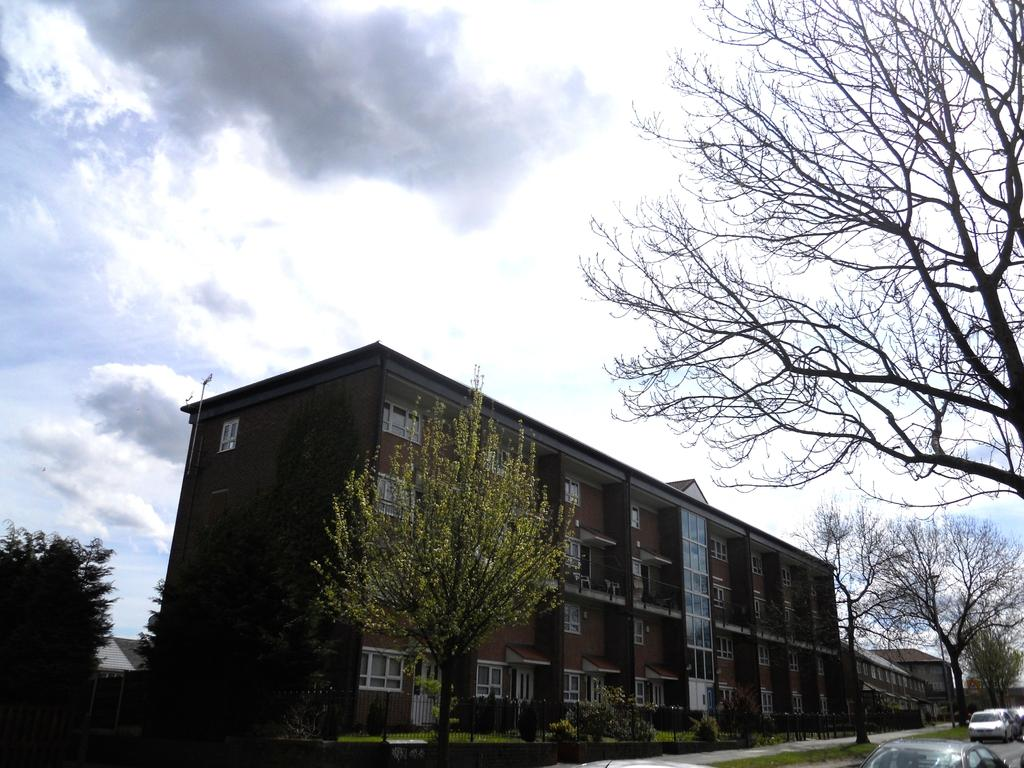What type of structure is present in the image? There is a building in the image. Are there any other structures near the building? Yes, there are houses beside the building. What can be seen in the image besides the structures? There are plenty of trees in the image. What is happening on the road in the image? There are vehicles moving on the road. What is visible in the background of the image? The sky is visible in the background of the image. What type of dirt can be seen on the rose in the image? There is no rose present in the image, so it is not possible to determine if there is any dirt on it. 